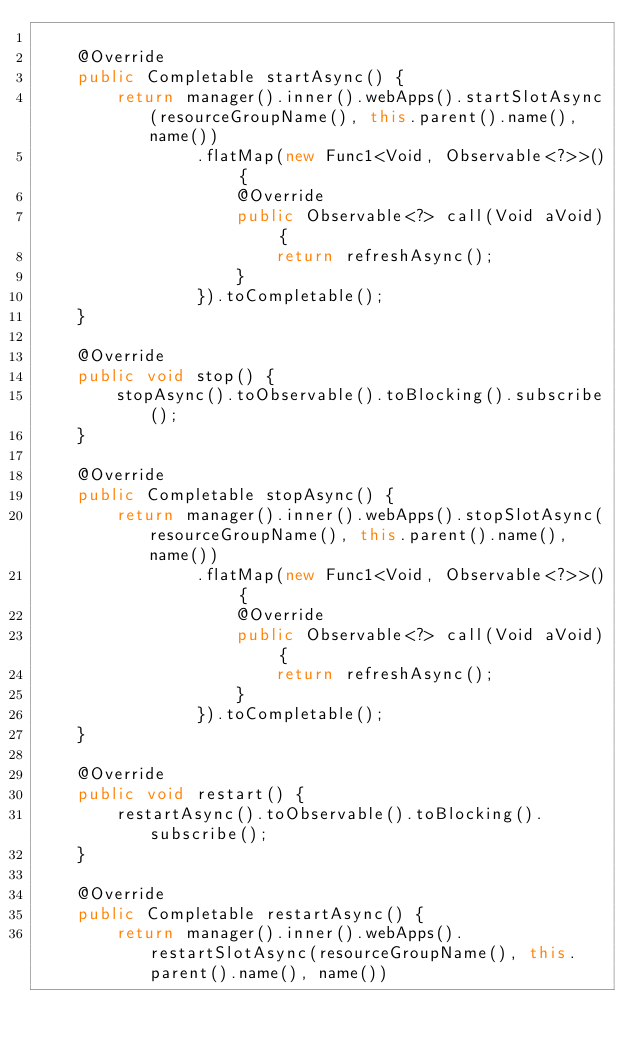Convert code to text. <code><loc_0><loc_0><loc_500><loc_500><_Java_>
    @Override
    public Completable startAsync() {
        return manager().inner().webApps().startSlotAsync(resourceGroupName(), this.parent().name(), name())
                .flatMap(new Func1<Void, Observable<?>>() {
                    @Override
                    public Observable<?> call(Void aVoid) {
                        return refreshAsync();
                    }
                }).toCompletable();
    }

    @Override
    public void stop() {
        stopAsync().toObservable().toBlocking().subscribe();
    }

    @Override
    public Completable stopAsync() {
        return manager().inner().webApps().stopSlotAsync(resourceGroupName(), this.parent().name(), name())
                .flatMap(new Func1<Void, Observable<?>>() {
                    @Override
                    public Observable<?> call(Void aVoid) {
                        return refreshAsync();
                    }
                }).toCompletable();
    }

    @Override
    public void restart() {
        restartAsync().toObservable().toBlocking().subscribe();
    }

    @Override
    public Completable restartAsync() {
        return manager().inner().webApps().restartSlotAsync(resourceGroupName(), this.parent().name(), name())</code> 